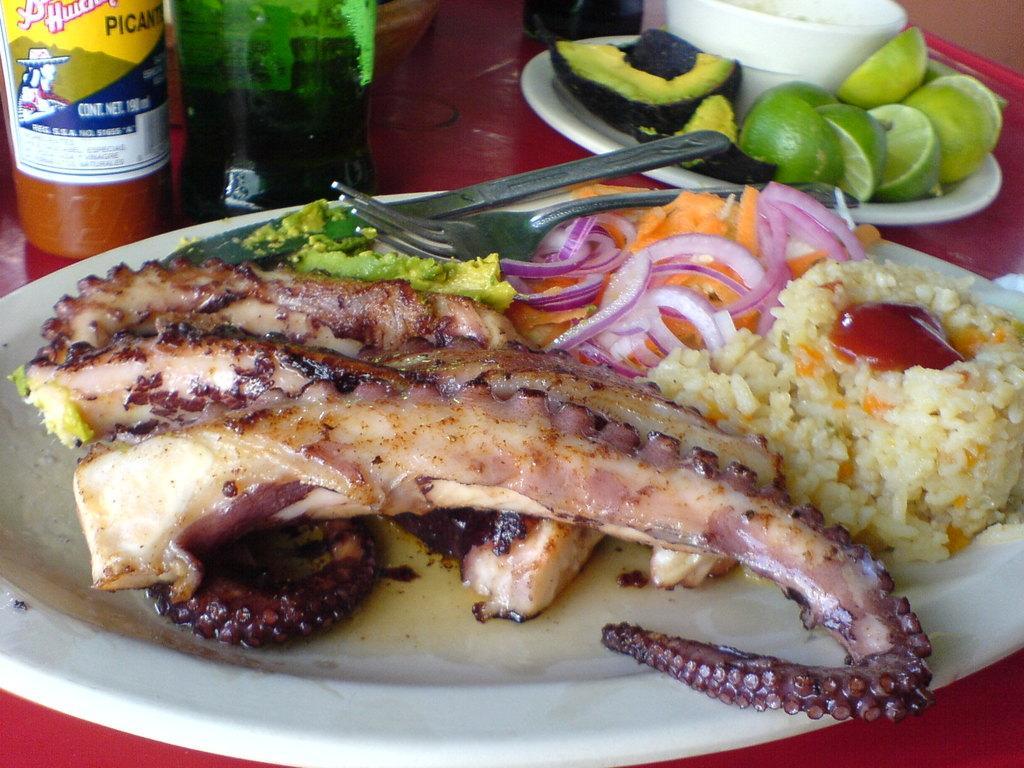Describe this image in one or two sentences. In the image we can see a table, on the table we can see some plates and bottles. In the plates we can see some food, knife and fork. 